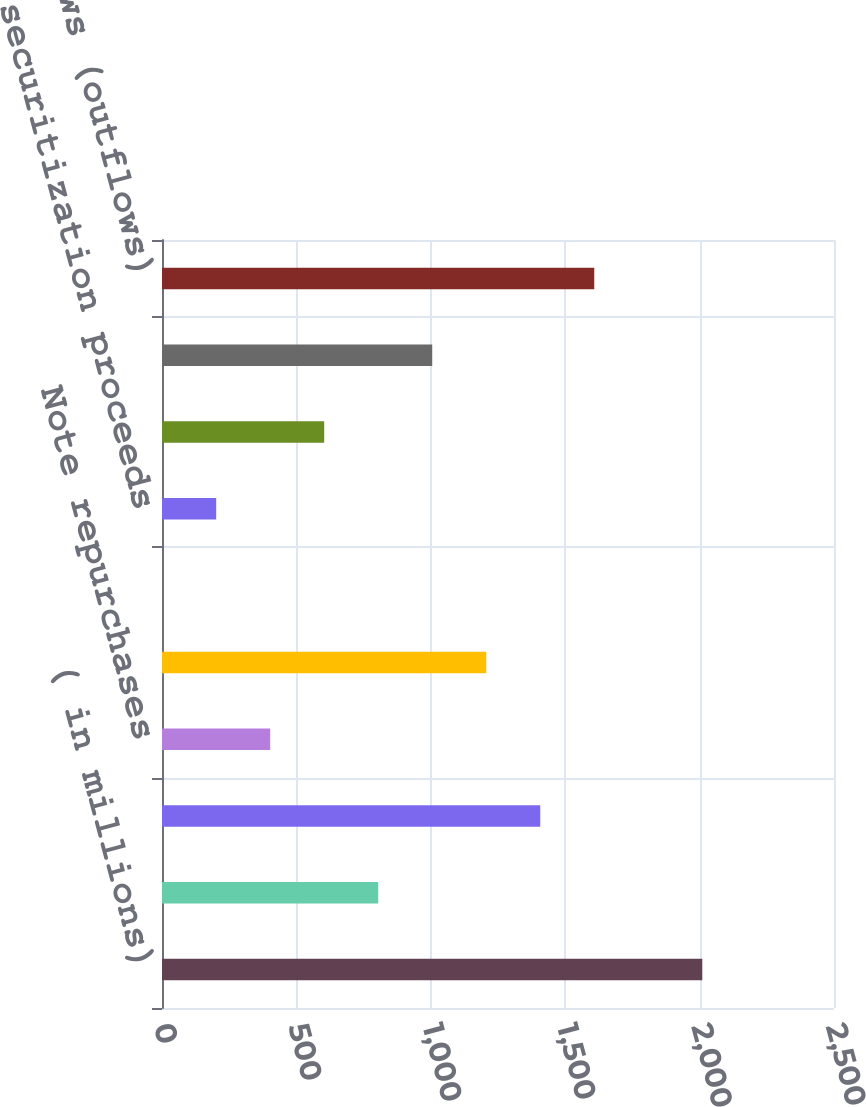<chart> <loc_0><loc_0><loc_500><loc_500><bar_chart><fcel>( in millions)<fcel>Timeshare segment development<fcel>Timeshare segment collections<fcel>Note repurchases<fcel>Financially reportable sales<fcel>Note securitization gains<fcel>Note securitization proceeds<fcel>Collection on retained<fcel>Other cash inflows (outflows)<fcel>Net cash inflows (outflows)<nl><fcel>2010<fcel>804.38<fcel>1407.19<fcel>402.52<fcel>1206.26<fcel>0.65<fcel>201.59<fcel>603.45<fcel>1005.32<fcel>1608.12<nl></chart> 